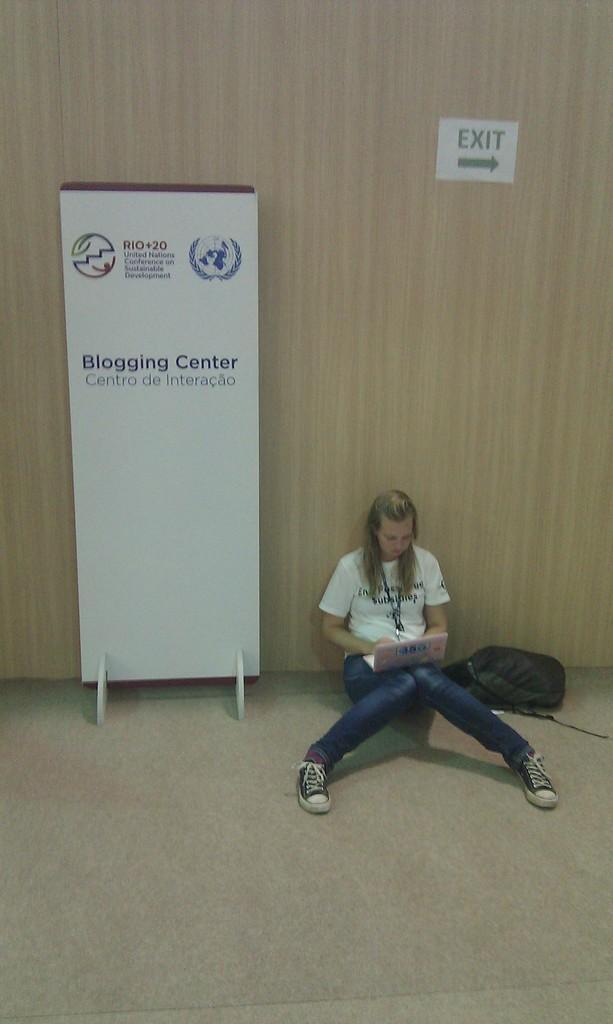In one or two sentences, can you explain what this image depicts? In this image there is a woman sitting on the floor. There is a laptop on her lap. Beside her there is a bag on the floor. Behind her there is a wooden wall. To the left there is a board near to the wall. There are logos and text on the board. 